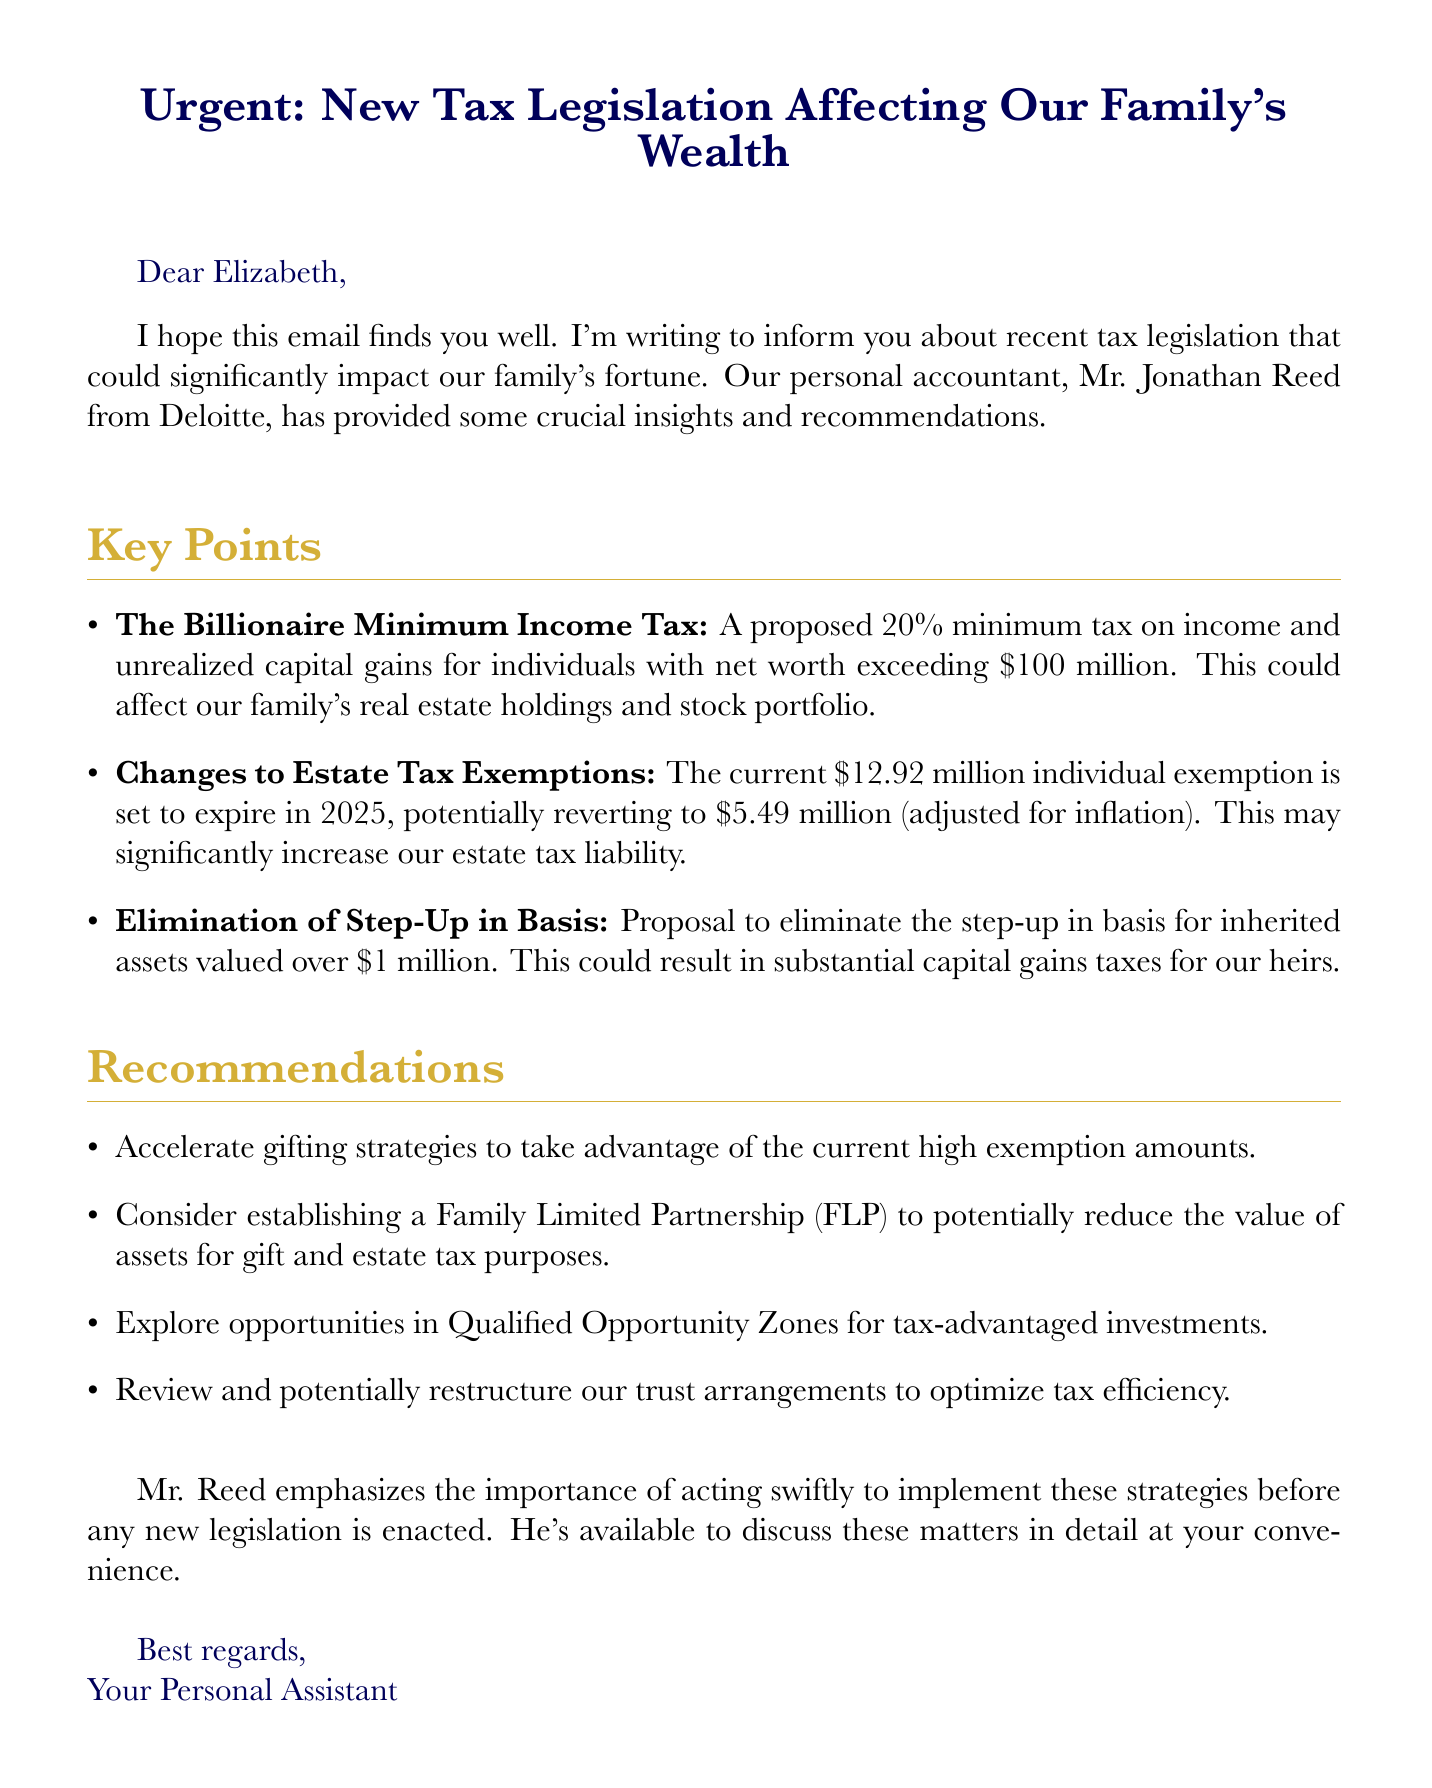What is the proposed minimum tax percentage? The document mentions a proposed 20% minimum tax on income and unrealized capital gains.
Answer: 20% What is the current individual estate tax exemption amount? The document states that the current individual exemption is $12.92 million.
Answer: $12.92 million What is the potential future individual estate tax exemption amount? The document indicates that it could revert to $5.49 million, adjusted for inflation.
Answer: $5.49 million What significant tax liability change is mentioned for inherited assets over $1 million? The document discusses the elimination of the step-up in basis for inherited assets valued over $1 million.
Answer: Elimination of step-up in basis Who provided the recommendations in the document? The personal accountant who provided insights and recommendations is Mr. Jonathan Reed from Deloitte.
Answer: Mr. Jonathan Reed What strategy is recommended to take advantage of high exemption amounts? The document recommends accelerating gifting strategies to utilize the current high exemption amounts.
Answer: Accelerate gifting strategies What is one strategy mentioned for reducing estate tax purposes? The document suggests considering establishing a Family Limited Partnership (FLP) as a strategy.
Answer: Family Limited Partnership (FLP) When is it crucial to act on these recommendations? The document emphasizes the importance of acting swiftly before any new legislation is enacted.
Answer: Before new legislation is enacted What type of investments does the recommendation suggest exploring? The document mentions exploring opportunities in Qualified Opportunity Zones for tax-advantaged investments.
Answer: Qualified Opportunity Zones 